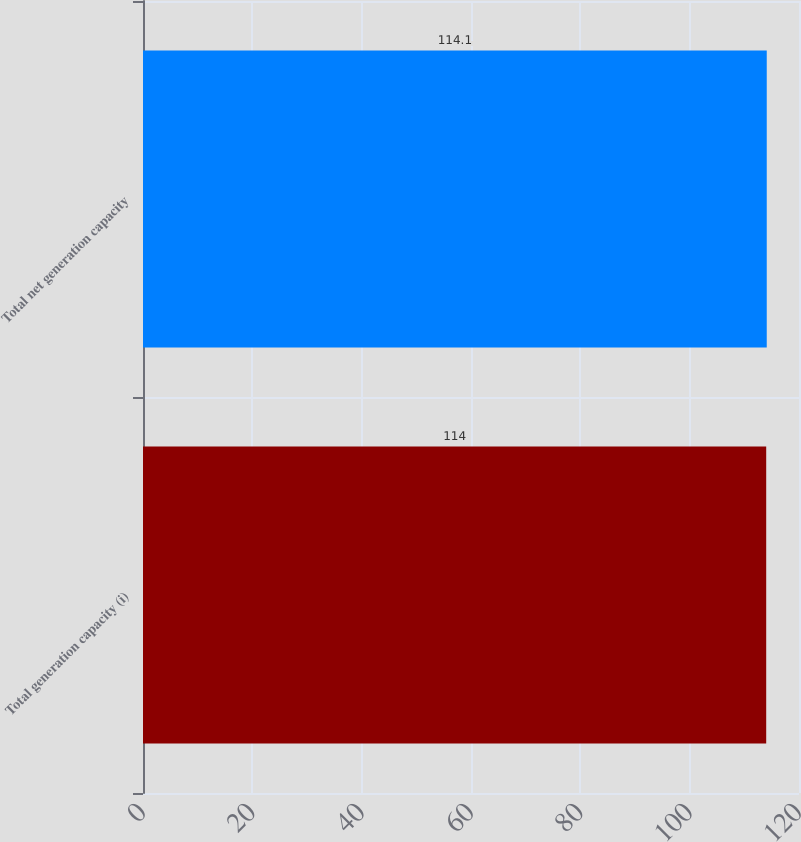Convert chart. <chart><loc_0><loc_0><loc_500><loc_500><bar_chart><fcel>Total generation capacity (i)<fcel>Total net generation capacity<nl><fcel>114<fcel>114.1<nl></chart> 